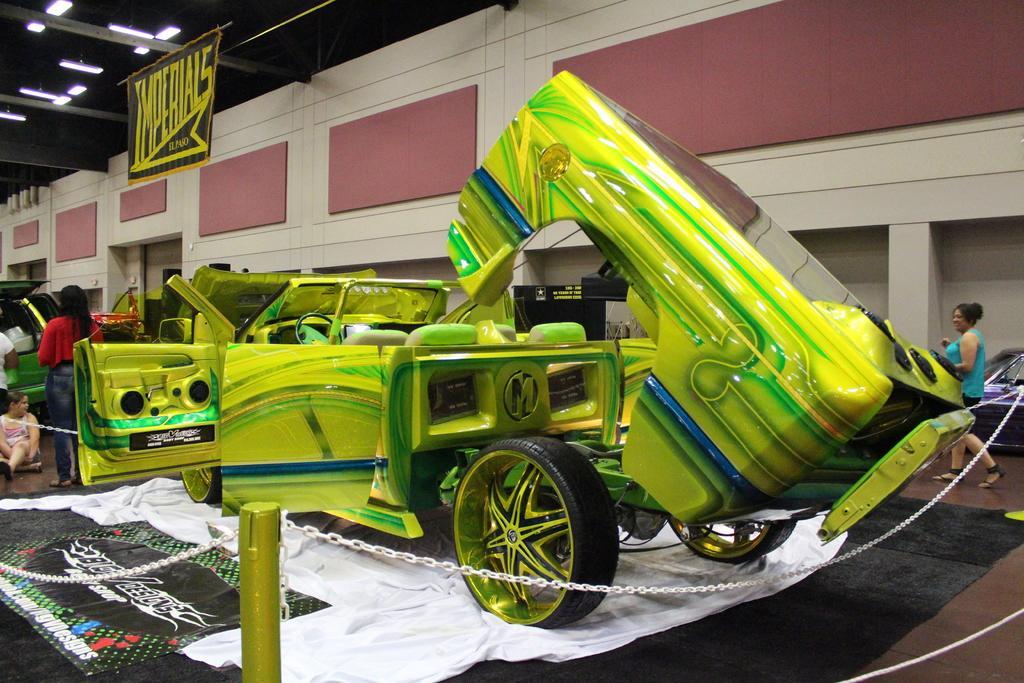Describe this image in one or two sentences. In this image in the center there is one vehicle, and in the background also there is one vehicle and some persons. At the bottom there is floor, on the floor there is one carpet and there is rod and some chains. In the background there is a wall and some boards and on the left side there is one board. On the board there is some text and at the top there is ceiling, pipes and some lights. 